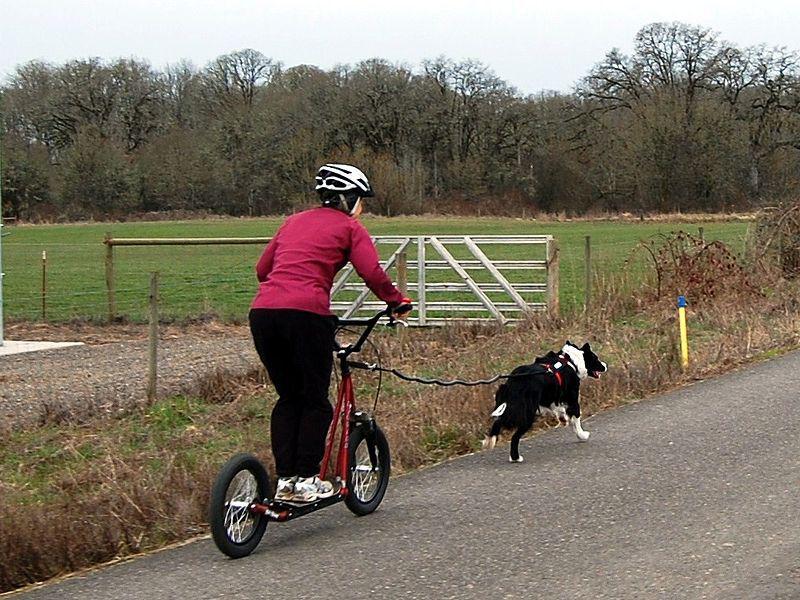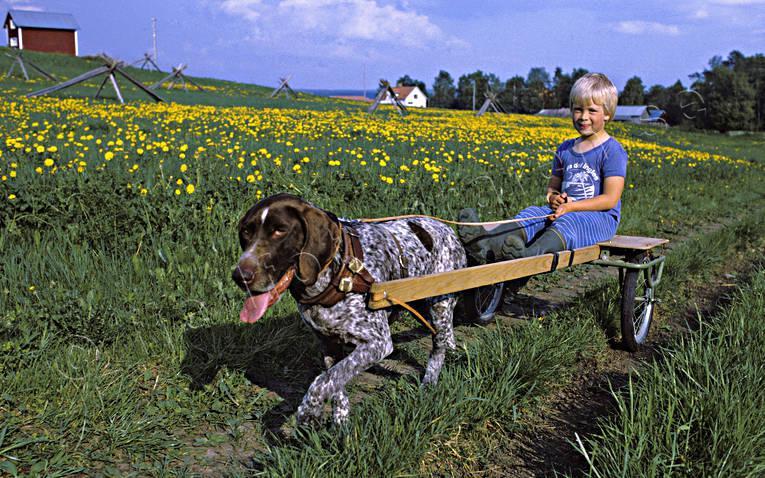The first image is the image on the left, the second image is the image on the right. Analyze the images presented: Is the assertion "There are two dogs." valid? Answer yes or no. Yes. The first image is the image on the left, the second image is the image on the right. For the images displayed, is the sentence "An image shows a person in a helmet riding a four-wheeled cart pulled by one dog diagonally to the right." factually correct? Answer yes or no. No. 